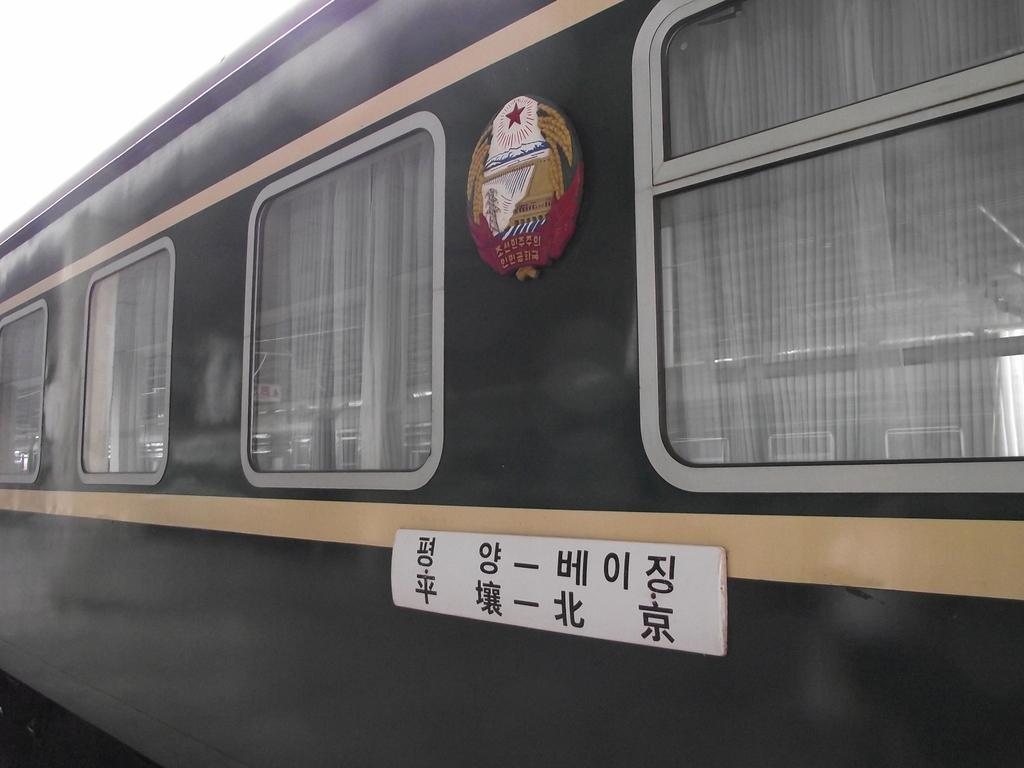What is the main subject of the image? The main subject of the image is a train. What features can be seen on the train? The train has windows and two boards attached to it. What is behind the windows of the train? There are curtains behind the windows of the train. What is written on the boards attached to the train? There is text on the boards. Can you see the seashore from the train in the image? There is no indication of a seashore in the image; it only shows a train with windows, curtains, and boards with text. How many accounts are visible on the train in the image? There is no mention of any accounts in the image; it only shows a train with windows, curtains, and boards with text. 